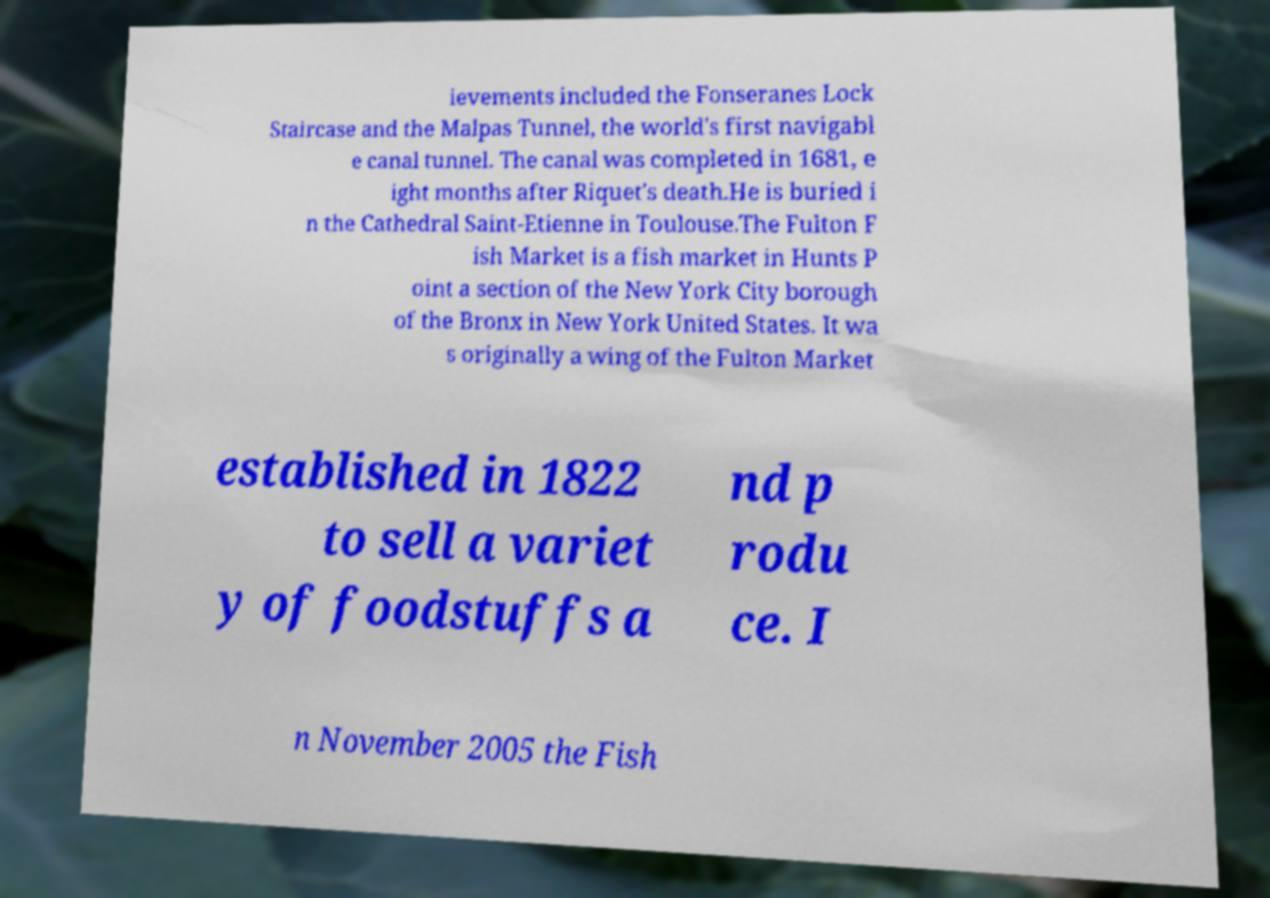Can you read and provide the text displayed in the image?This photo seems to have some interesting text. Can you extract and type it out for me? ievements included the Fonseranes Lock Staircase and the Malpas Tunnel, the world's first navigabl e canal tunnel. The canal was completed in 1681, e ight months after Riquet's death.He is buried i n the Cathedral Saint-Etienne in Toulouse.The Fulton F ish Market is a fish market in Hunts P oint a section of the New York City borough of the Bronx in New York United States. It wa s originally a wing of the Fulton Market established in 1822 to sell a variet y of foodstuffs a nd p rodu ce. I n November 2005 the Fish 